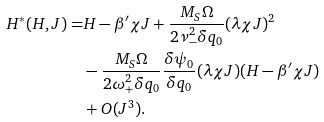<formula> <loc_0><loc_0><loc_500><loc_500>H ^ { * } ( H , J ) = & H - \beta ^ { \prime } \chi J + \frac { M _ { S } \Omega } { 2 \nu _ { - } ^ { 2 } \delta q _ { 0 } } ( \lambda \chi J ) ^ { 2 } \\ & - \frac { M _ { S } \Omega } { 2 \omega _ { + } ^ { 2 } \delta q _ { 0 } } \frac { \delta \psi _ { 0 } } { \delta q _ { 0 } } ( \lambda \chi J ) ( H - \beta ^ { \prime } \chi J ) \\ & + O ( J ^ { 3 } ) .</formula> 